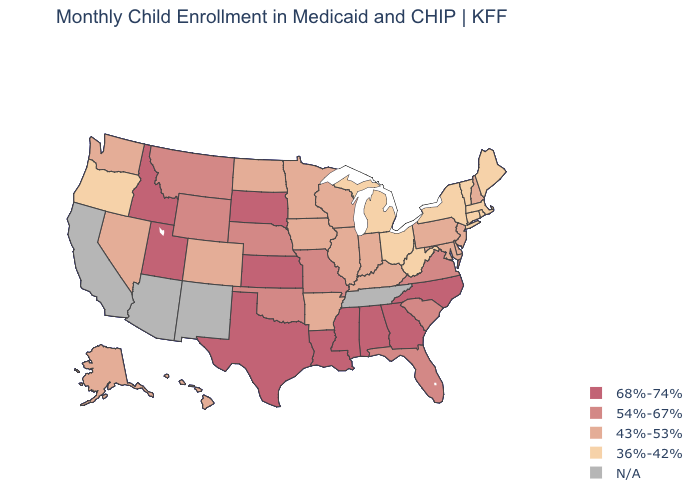Does the map have missing data?
Quick response, please. Yes. What is the highest value in the MidWest ?
Write a very short answer. 68%-74%. Does the map have missing data?
Quick response, please. Yes. Name the states that have a value in the range 54%-67%?
Answer briefly. Florida, Missouri, Montana, Nebraska, Oklahoma, South Carolina, Virginia, Wyoming. Does the first symbol in the legend represent the smallest category?
Keep it brief. No. Name the states that have a value in the range 68%-74%?
Keep it brief. Alabama, Georgia, Idaho, Kansas, Louisiana, Mississippi, North Carolina, South Dakota, Texas, Utah. Does Mississippi have the highest value in the USA?
Write a very short answer. Yes. Does Alaska have the lowest value in the USA?
Keep it brief. No. Does the map have missing data?
Write a very short answer. Yes. Does the first symbol in the legend represent the smallest category?
Give a very brief answer. No. Name the states that have a value in the range N/A?
Answer briefly. Arizona, California, New Mexico, Tennessee. Does the first symbol in the legend represent the smallest category?
Keep it brief. No. Is the legend a continuous bar?
Be succinct. No. Name the states that have a value in the range N/A?
Answer briefly. Arizona, California, New Mexico, Tennessee. Name the states that have a value in the range 68%-74%?
Concise answer only. Alabama, Georgia, Idaho, Kansas, Louisiana, Mississippi, North Carolina, South Dakota, Texas, Utah. 